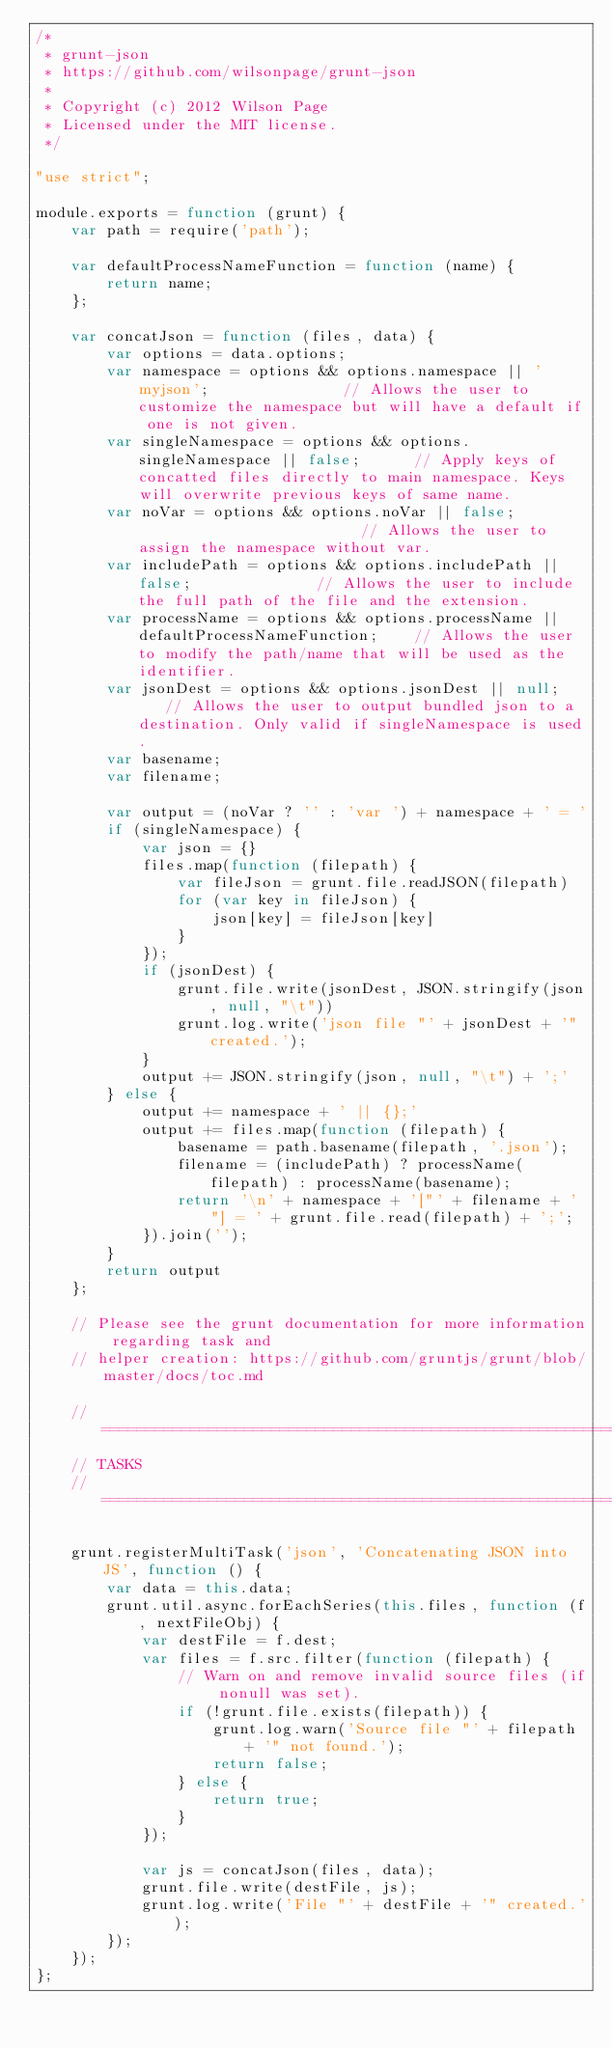Convert code to text. <code><loc_0><loc_0><loc_500><loc_500><_JavaScript_>/*
 * grunt-json
 * https://github.com/wilsonpage/grunt-json
 *
 * Copyright (c) 2012 Wilson Page
 * Licensed under the MIT license.
 */

"use strict";

module.exports = function (grunt) {
    var path = require('path');

    var defaultProcessNameFunction = function (name) {
        return name;
    };

    var concatJson = function (files, data) {
        var options = data.options;
        var namespace = options && options.namespace || 'myjson';               // Allows the user to customize the namespace but will have a default if one is not given.
        var singleNamespace = options && options.singleNamespace || false;      // Apply keys of concatted files directly to main namespace. Keys will overwrite previous keys of same name. 
        var noVar = options && options.noVar || false;                          // Allows the user to assign the namespace without var.
        var includePath = options && options.includePath || false;              // Allows the user to include the full path of the file and the extension.
        var processName = options && options.processName || defaultProcessNameFunction;    // Allows the user to modify the path/name that will be used as the identifier.
        var jsonDest = options && options.jsonDest || null;    // Allows the user to output bundled json to a destination. Only valid if singleNamespace is used.
        var basename;
        var filename;

        var output = (noVar ? '' : 'var ') + namespace + ' = '
        if (singleNamespace) {
            var json = {}
            files.map(function (filepath) {
                var fileJson = grunt.file.readJSON(filepath)
                for (var key in fileJson) {
                    json[key] = fileJson[key]
                }
            });
            if (jsonDest) {
                grunt.file.write(jsonDest, JSON.stringify(json, null, "\t"))
                grunt.log.write('json file "' + jsonDest + '" created.');
            }
            output += JSON.stringify(json, null, "\t") + ';'
        } else {
            output += namespace + ' || {};'
            output += files.map(function (filepath) {
                basename = path.basename(filepath, '.json');
                filename = (includePath) ? processName(filepath) : processName(basename);
                return '\n' + namespace + '["' + filename + '"] = ' + grunt.file.read(filepath) + ';';
            }).join('');
        }
        return output
    };

    // Please see the grunt documentation for more information regarding task and
    // helper creation: https://github.com/gruntjs/grunt/blob/master/docs/toc.md

    // ==========================================================================
    // TASKS
    // ==========================================================================

    grunt.registerMultiTask('json', 'Concatenating JSON into JS', function () {
        var data = this.data;
        grunt.util.async.forEachSeries(this.files, function (f, nextFileObj) {
            var destFile = f.dest;
            var files = f.src.filter(function (filepath) {
                // Warn on and remove invalid source files (if nonull was set).
                if (!grunt.file.exists(filepath)) {
                    grunt.log.warn('Source file "' + filepath + '" not found.');
                    return false;
                } else {
                    return true;
                }
            });

            var js = concatJson(files, data);
            grunt.file.write(destFile, js);
            grunt.log.write('File "' + destFile + '" created.');
        });
    });
};
</code> 